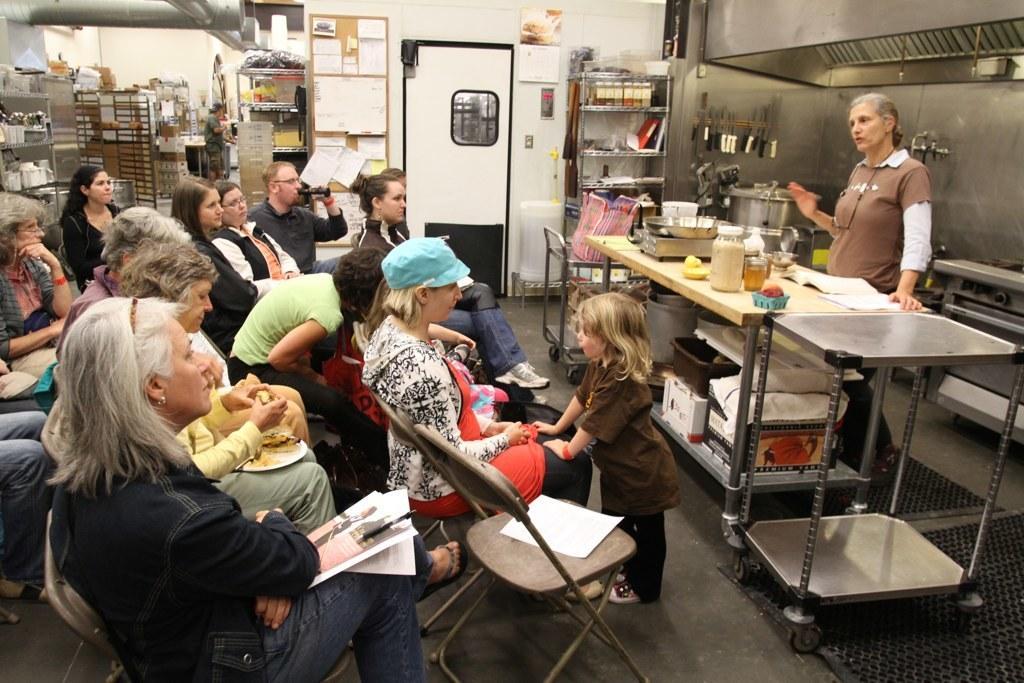Could you give a brief overview of what you see in this image? A woman is standing and speaking in the left group of people are sitting on the chairs. 